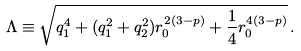Convert formula to latex. <formula><loc_0><loc_0><loc_500><loc_500>\Lambda \equiv \sqrt { q _ { 1 } ^ { 4 } + ( q _ { 1 } ^ { 2 } + q _ { 2 } ^ { 2 } ) r _ { 0 } ^ { 2 ( 3 - p ) } + \frac { 1 } { 4 } r _ { 0 } ^ { 4 ( 3 - p ) } } \, .</formula> 